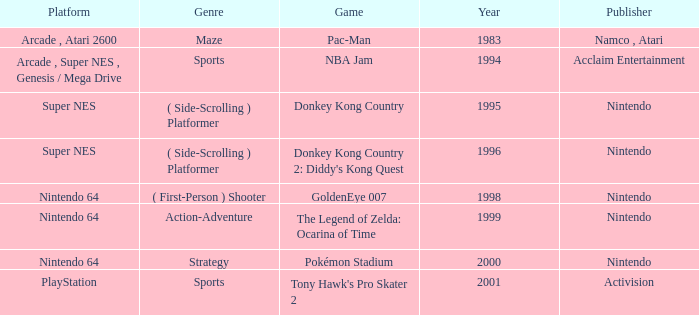Which Genre has a Year larger than 1999, and a Game of tony hawk's pro skater 2? Sports. 